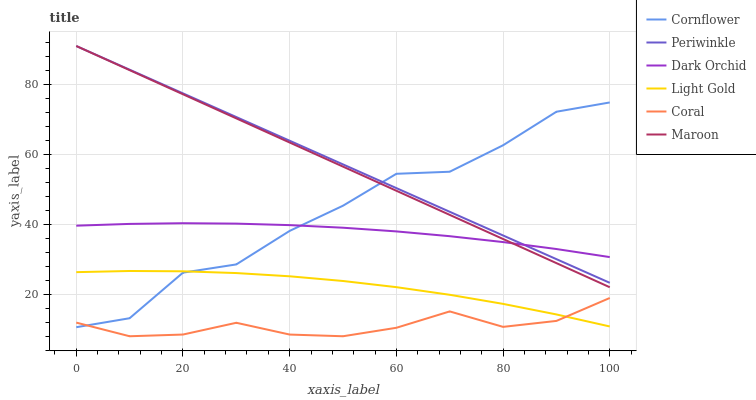Does Maroon have the minimum area under the curve?
Answer yes or no. No. Does Maroon have the maximum area under the curve?
Answer yes or no. No. Is Coral the smoothest?
Answer yes or no. No. Is Coral the roughest?
Answer yes or no. No. Does Maroon have the lowest value?
Answer yes or no. No. Does Coral have the highest value?
Answer yes or no. No. Is Coral less than Periwinkle?
Answer yes or no. Yes. Is Dark Orchid greater than Coral?
Answer yes or no. Yes. Does Coral intersect Periwinkle?
Answer yes or no. No. 